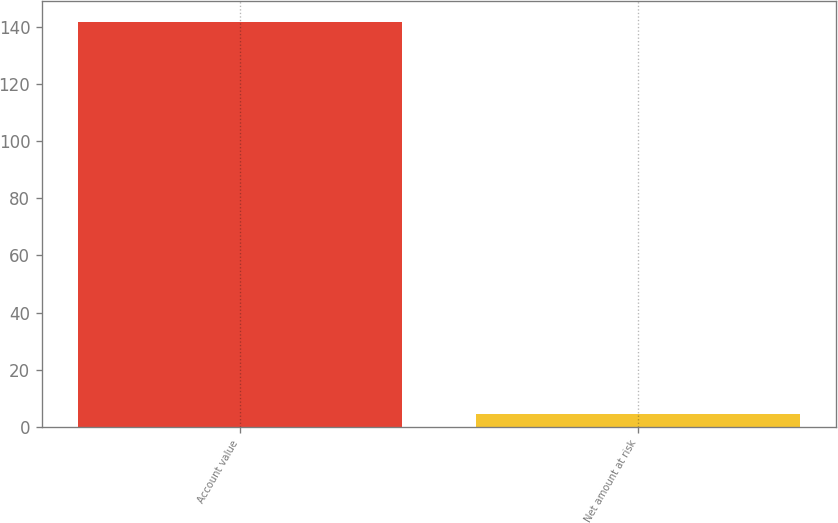Convert chart to OTSL. <chart><loc_0><loc_0><loc_500><loc_500><bar_chart><fcel>Account value<fcel>Net amount at risk<nl><fcel>142<fcel>4.5<nl></chart> 